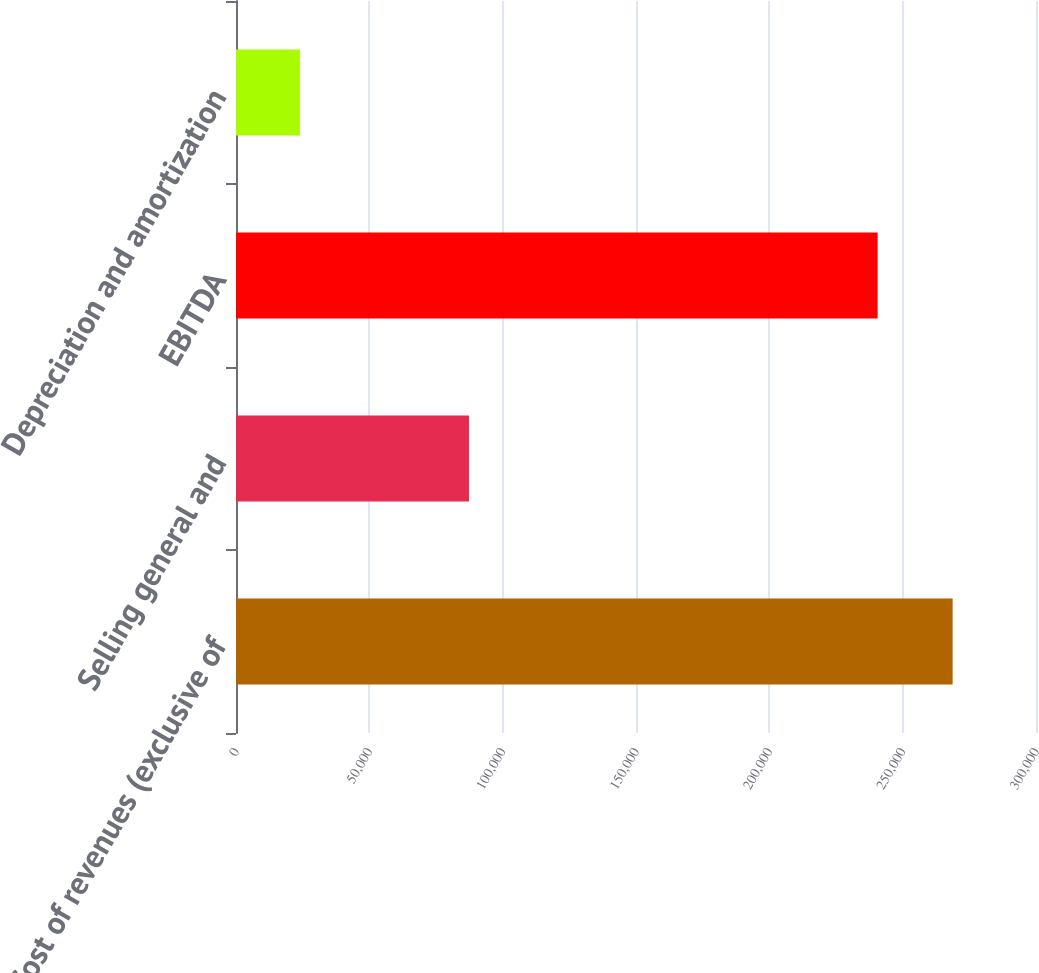<chart> <loc_0><loc_0><loc_500><loc_500><bar_chart><fcel>Cost of revenues (exclusive of<fcel>Selling general and<fcel>EBITDA<fcel>Depreciation and amortization<nl><fcel>268742<fcel>87384<fcel>240623<fcel>23956<nl></chart> 